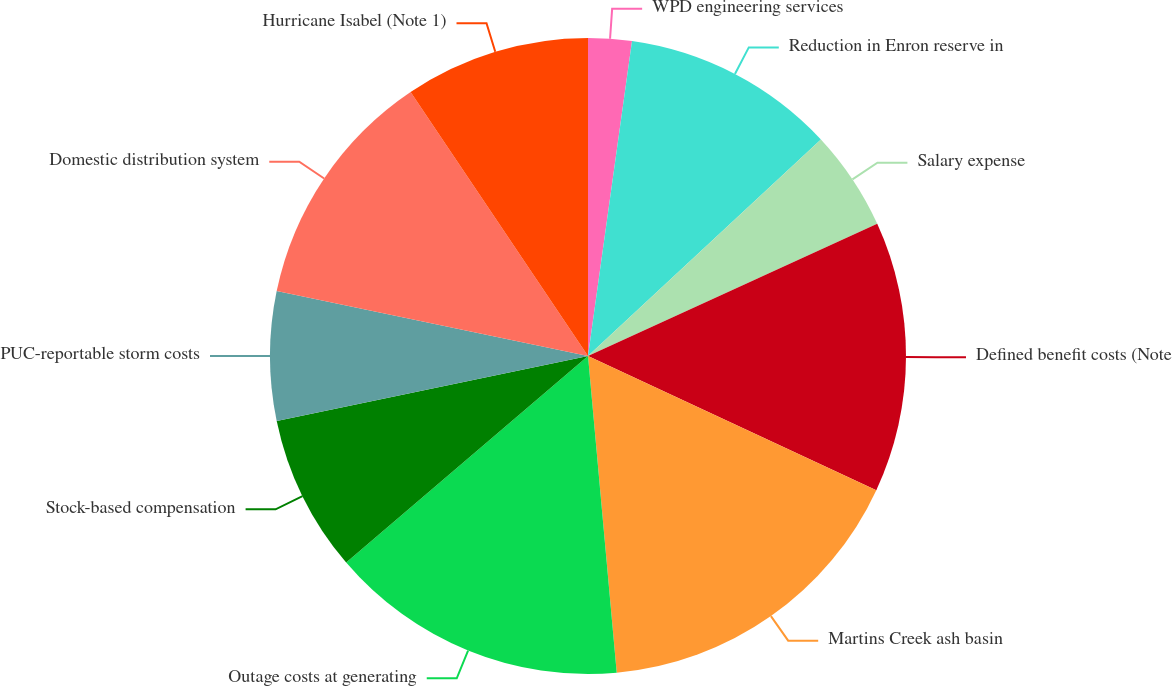<chart> <loc_0><loc_0><loc_500><loc_500><pie_chart><fcel>WPD engineering services<fcel>Reduction in Enron reserve in<fcel>Salary expense<fcel>Defined benefit costs (Note<fcel>Martins Creek ash basin<fcel>Outage costs at generating<fcel>Stock-based compensation<fcel>PUC-reportable storm costs<fcel>Domestic distribution system<fcel>Hurricane Isabel (Note 1)<nl><fcel>2.21%<fcel>10.87%<fcel>5.1%<fcel>13.75%<fcel>16.63%<fcel>15.19%<fcel>7.98%<fcel>6.54%<fcel>12.31%<fcel>9.42%<nl></chart> 